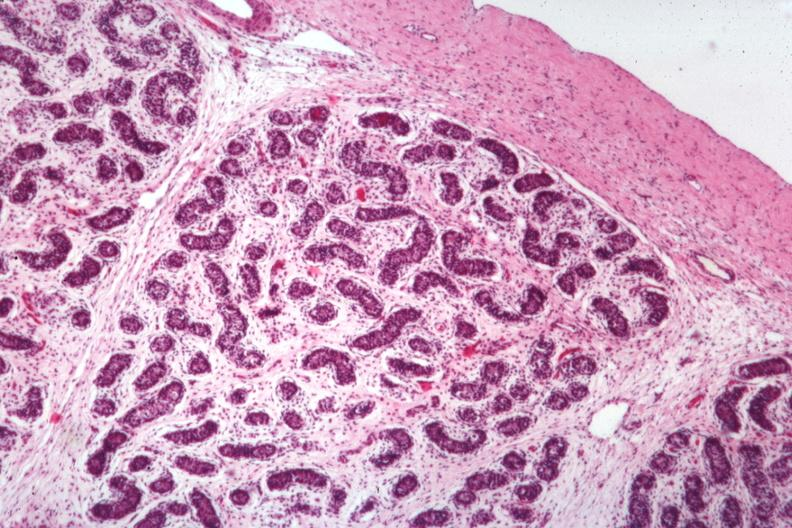does this image show 7yo with craniopharyngioma and underdeveloped penis?
Answer the question using a single word or phrase. Yes 